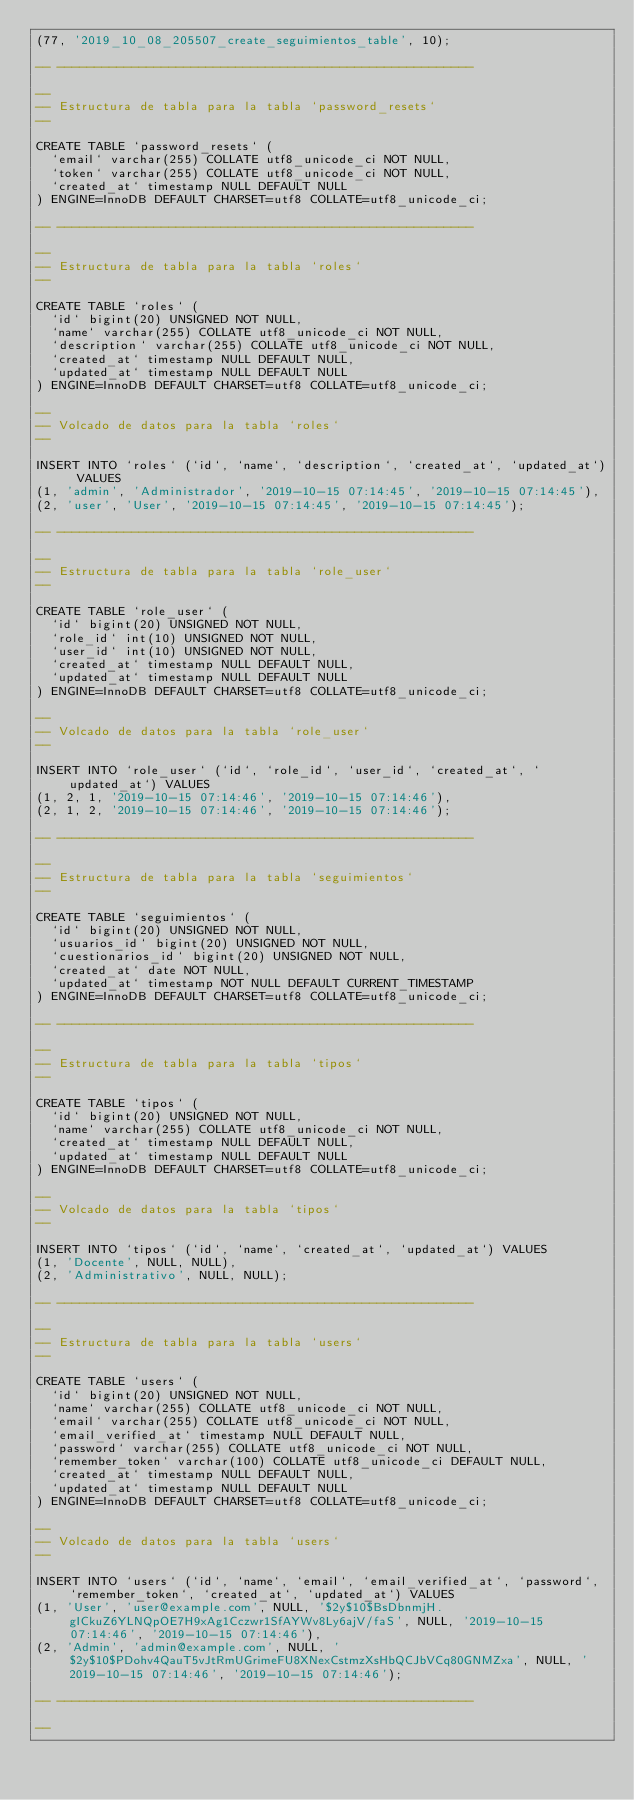Convert code to text. <code><loc_0><loc_0><loc_500><loc_500><_SQL_>(77, '2019_10_08_205507_create_seguimientos_table', 10);

-- --------------------------------------------------------

--
-- Estructura de tabla para la tabla `password_resets`
--

CREATE TABLE `password_resets` (
  `email` varchar(255) COLLATE utf8_unicode_ci NOT NULL,
  `token` varchar(255) COLLATE utf8_unicode_ci NOT NULL,
  `created_at` timestamp NULL DEFAULT NULL
) ENGINE=InnoDB DEFAULT CHARSET=utf8 COLLATE=utf8_unicode_ci;

-- --------------------------------------------------------

--
-- Estructura de tabla para la tabla `roles`
--

CREATE TABLE `roles` (
  `id` bigint(20) UNSIGNED NOT NULL,
  `name` varchar(255) COLLATE utf8_unicode_ci NOT NULL,
  `description` varchar(255) COLLATE utf8_unicode_ci NOT NULL,
  `created_at` timestamp NULL DEFAULT NULL,
  `updated_at` timestamp NULL DEFAULT NULL
) ENGINE=InnoDB DEFAULT CHARSET=utf8 COLLATE=utf8_unicode_ci;

--
-- Volcado de datos para la tabla `roles`
--

INSERT INTO `roles` (`id`, `name`, `description`, `created_at`, `updated_at`) VALUES
(1, 'admin', 'Administrador', '2019-10-15 07:14:45', '2019-10-15 07:14:45'),
(2, 'user', 'User', '2019-10-15 07:14:45', '2019-10-15 07:14:45');

-- --------------------------------------------------------

--
-- Estructura de tabla para la tabla `role_user`
--

CREATE TABLE `role_user` (
  `id` bigint(20) UNSIGNED NOT NULL,
  `role_id` int(10) UNSIGNED NOT NULL,
  `user_id` int(10) UNSIGNED NOT NULL,
  `created_at` timestamp NULL DEFAULT NULL,
  `updated_at` timestamp NULL DEFAULT NULL
) ENGINE=InnoDB DEFAULT CHARSET=utf8 COLLATE=utf8_unicode_ci;

--
-- Volcado de datos para la tabla `role_user`
--

INSERT INTO `role_user` (`id`, `role_id`, `user_id`, `created_at`, `updated_at`) VALUES
(1, 2, 1, '2019-10-15 07:14:46', '2019-10-15 07:14:46'),
(2, 1, 2, '2019-10-15 07:14:46', '2019-10-15 07:14:46');

-- --------------------------------------------------------

--
-- Estructura de tabla para la tabla `seguimientos`
--

CREATE TABLE `seguimientos` (
  `id` bigint(20) UNSIGNED NOT NULL,
  `usuarios_id` bigint(20) UNSIGNED NOT NULL,
  `cuestionarios_id` bigint(20) UNSIGNED NOT NULL,
  `created_at` date NOT NULL,
  `updated_at` timestamp NOT NULL DEFAULT CURRENT_TIMESTAMP
) ENGINE=InnoDB DEFAULT CHARSET=utf8 COLLATE=utf8_unicode_ci;

-- --------------------------------------------------------

--
-- Estructura de tabla para la tabla `tipos`
--

CREATE TABLE `tipos` (
  `id` bigint(20) UNSIGNED NOT NULL,
  `name` varchar(255) COLLATE utf8_unicode_ci NOT NULL,
  `created_at` timestamp NULL DEFAULT NULL,
  `updated_at` timestamp NULL DEFAULT NULL
) ENGINE=InnoDB DEFAULT CHARSET=utf8 COLLATE=utf8_unicode_ci;

--
-- Volcado de datos para la tabla `tipos`
--

INSERT INTO `tipos` (`id`, `name`, `created_at`, `updated_at`) VALUES
(1, 'Docente', NULL, NULL),
(2, 'Administrativo', NULL, NULL);

-- --------------------------------------------------------

--
-- Estructura de tabla para la tabla `users`
--

CREATE TABLE `users` (
  `id` bigint(20) UNSIGNED NOT NULL,
  `name` varchar(255) COLLATE utf8_unicode_ci NOT NULL,
  `email` varchar(255) COLLATE utf8_unicode_ci NOT NULL,
  `email_verified_at` timestamp NULL DEFAULT NULL,
  `password` varchar(255) COLLATE utf8_unicode_ci NOT NULL,
  `remember_token` varchar(100) COLLATE utf8_unicode_ci DEFAULT NULL,
  `created_at` timestamp NULL DEFAULT NULL,
  `updated_at` timestamp NULL DEFAULT NULL
) ENGINE=InnoDB DEFAULT CHARSET=utf8 COLLATE=utf8_unicode_ci;

--
-- Volcado de datos para la tabla `users`
--

INSERT INTO `users` (`id`, `name`, `email`, `email_verified_at`, `password`, `remember_token`, `created_at`, `updated_at`) VALUES
(1, 'User', 'user@example.com', NULL, '$2y$10$BsDbnmjH.gICkuZ6YLNQpOE7H9xAg1Cczwr1SfAYWv8Ly6ajV/faS', NULL, '2019-10-15 07:14:46', '2019-10-15 07:14:46'),
(2, 'Admin', 'admin@example.com', NULL, '$2y$10$PDohv4QauT5vJtRmUGrimeFU8XNexCstmzXsHbQCJbVCq80GNMZxa', NULL, '2019-10-15 07:14:46', '2019-10-15 07:14:46');

-- --------------------------------------------------------

--</code> 